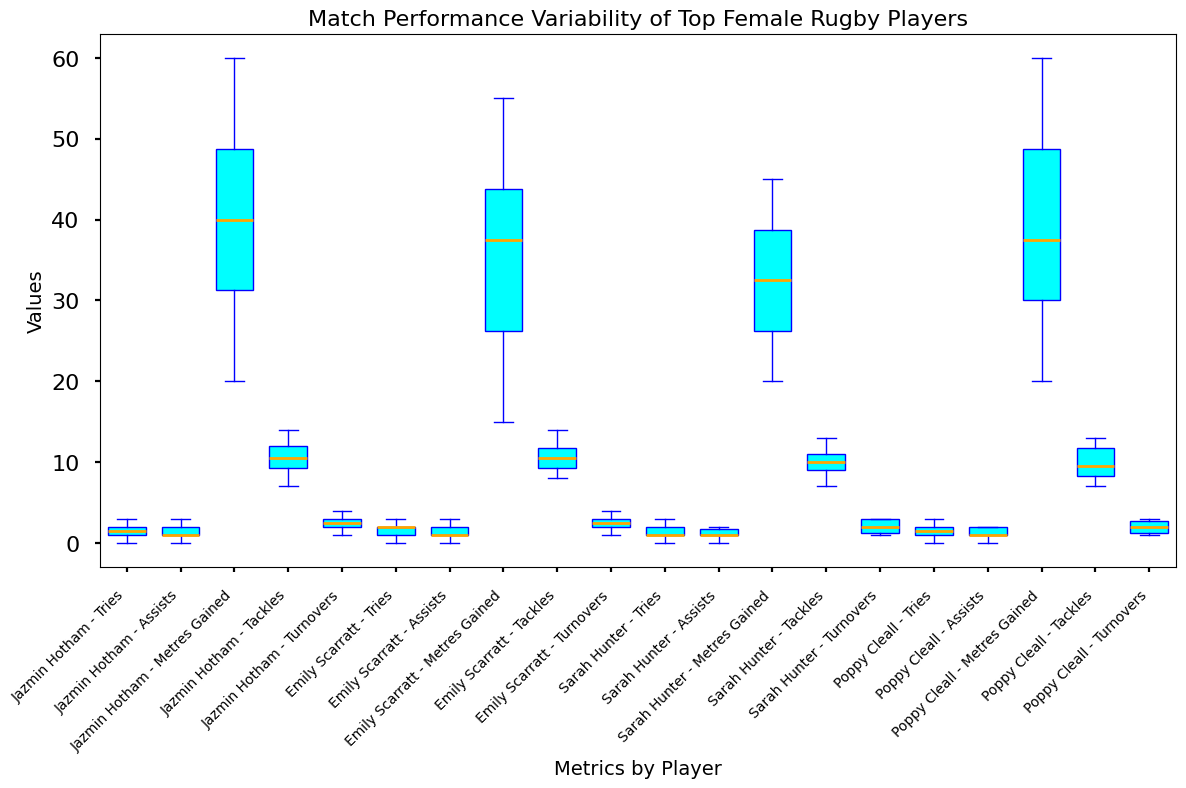What is the median number of tries scored by Jazmin Hotham? To find the median, locate the middle value in the sorted list of tries scored by Jazmin Hotham: [0, 1, 1, 1, 2, 2, 2, 2, 3, 3]. The median is the average of the 5th and 6th values: (2+2)/2 = 2.
Answer: 2 Which player has the highest median value in Metres Gained? Compare the medians of Metres Gained for each player. Jazmin Hotham: sorted list [20, 25, 30, 35, 40, 40, 45, 50, 55, 60], median = (40+40)/2 = 40. Emily Scarratt: sorted list [15, 20, 25, 30, 35, 40, 40, 45, 50, 55], median = (35+40)/2 = 37.5. Sarah Hunter: sorted list [20, 25, 25, 30, 35, 35, 40, 40, 45], median = 35. Poppy Cleall: sorted list [20, 25, 30, 30, 35, 40, 45, 50, 55, 60], median = (35+40)/2 = 37.5. Hence, Jazmin Hotham has the highest median value of 40.
Answer: Jazmin Hotham Is Jazmin Hotham's variability in Tackles greater or less than Emily Scarratt's? Variability can be assessed by the interquartile range (IQR), which is the range between the 1st quartile (Q1) and the 3rd quartile (Q3). Jazmin Hotham: sorted list [7, 8, 9, 10, 10, 11, 12, 12, 13, 14], Q1 = 9.5, Q3 = 12, IQR = 12-9.5 = 2.5. Emily Scarratt: sorted list [8, 9, 9, 10, 10, 11, 11, 12, 13, 14], Q1 = 9, Q3 = 12, IQR = 3. Therefore, Emily Scarratt has greater variability in Tackles than Jazmin Hotham.
Answer: Less What is the range of Turnovers for Poppy Cleall? The range is the difference between the maximum and minimum values. For Poppy Cleall: [1, 1, 1, 2, 2, 2, 3, 3, 3, 3]. The range is 3-1 = 2.
Answer: 2 How does the median number of Assists compare between Sarah Hunter and Poppy Cleall? To find the median of Assists: Sarah Hunter: sorted list [0, 0, 1, 1, 1, 1, 2, 2, 2, 2], median = (1+1)/2 = 1. Poppy Cleall: sorted list [0, 0, 1, 1, 1, 1, 2, 2, 2, 2], median = (1+1)/2 = 1. Therefore, median values for both are equal.
Answer: Equal Among the four players, who has the highest median value in Tackles? Compare the medians of Tackles: Jazmin Hotham: sorted list [7, 8, 9, 10, 10, 11, 12, 12, 13, 14], median = (10+11)/2 = 10.5. Emily Scarratt: sorted list [8, 9, 9, 10, 10, 11, 11, 12, 13, 14], median = (10+11)/2 = 10.5. Sarah Hunter: sorted list [7, 8, 9, 9, 10, 11, 11, 12, 12, 13], median = (9+10)/2 = 9.5. Poppy Cleall: sorted list [7, 8, 9, 10, 11, 12, 12, 13], median = (10+11)/2 = 10.5. All players except Sarah Hunter have the median 10.5.
Answer: Jazmin Hotham, Emily Scarratt, Poppy Cleall 